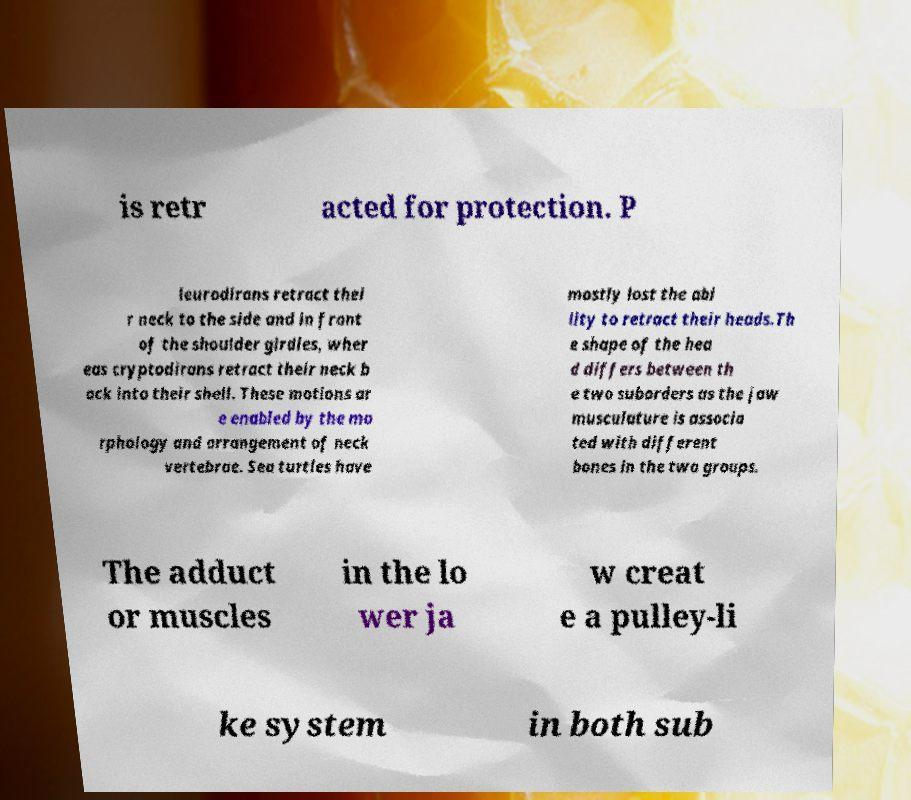Could you assist in decoding the text presented in this image and type it out clearly? is retr acted for protection. P leurodirans retract thei r neck to the side and in front of the shoulder girdles, wher eas cryptodirans retract their neck b ack into their shell. These motions ar e enabled by the mo rphology and arrangement of neck vertebrae. Sea turtles have mostly lost the abi lity to retract their heads.Th e shape of the hea d differs between th e two suborders as the jaw musculature is associa ted with different bones in the two groups. The adduct or muscles in the lo wer ja w creat e a pulley-li ke system in both sub 